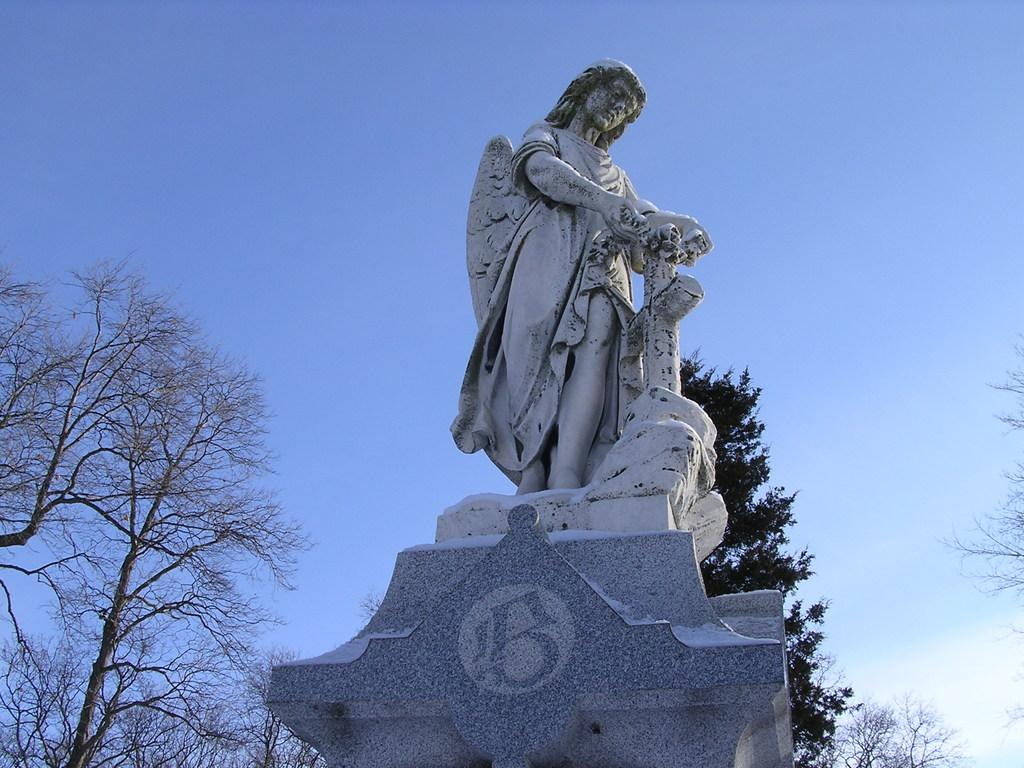What is the main subject in the image? There is a statue in the image. What is the statue resting on? The statue is on an object. What can be seen in the background of the image? There are trees and the sky visible in the background of the image. What type of leather material is used to make the trail in the image? There is no trail present in the image, and therefore no leather material can be observed. 